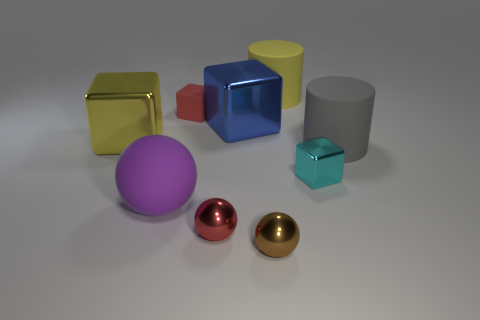What is the size of the metallic cube in front of the large metallic object that is on the left side of the big purple sphere?
Your response must be concise. Small. Do the large yellow object that is to the left of the big blue metal object and the small thing behind the gray matte cylinder have the same shape?
Give a very brief answer. Yes. The big matte object that is both on the left side of the gray thing and behind the small cyan metal cube is what color?
Your answer should be compact. Yellow. Is there another thing of the same color as the tiny matte object?
Provide a short and direct response. Yes. What color is the small shiny object behind the large purple sphere?
Ensure brevity in your answer.  Cyan. Are there any big yellow things on the right side of the large shiny thing left of the small red rubber object?
Provide a short and direct response. Yes. There is a tiny matte block; is it the same color as the tiny sphere left of the blue metal thing?
Offer a very short reply. Yes. Is there a large yellow object made of the same material as the big blue object?
Provide a succinct answer. Yes. How many purple matte objects are there?
Make the answer very short. 1. There is a big object behind the tiny red thing behind the tiny red ball; what is it made of?
Your answer should be compact. Rubber. 